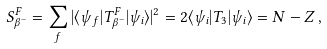Convert formula to latex. <formula><loc_0><loc_0><loc_500><loc_500>S _ { \beta ^ { - } } ^ { F } = \sum _ { f } | \langle \psi _ { f } | T _ { \beta ^ { - } } ^ { F } | \psi _ { i } \rangle | ^ { 2 } = 2 \langle \psi _ { i } | T _ { 3 } | \psi _ { i } \rangle = N - Z \, ,</formula> 